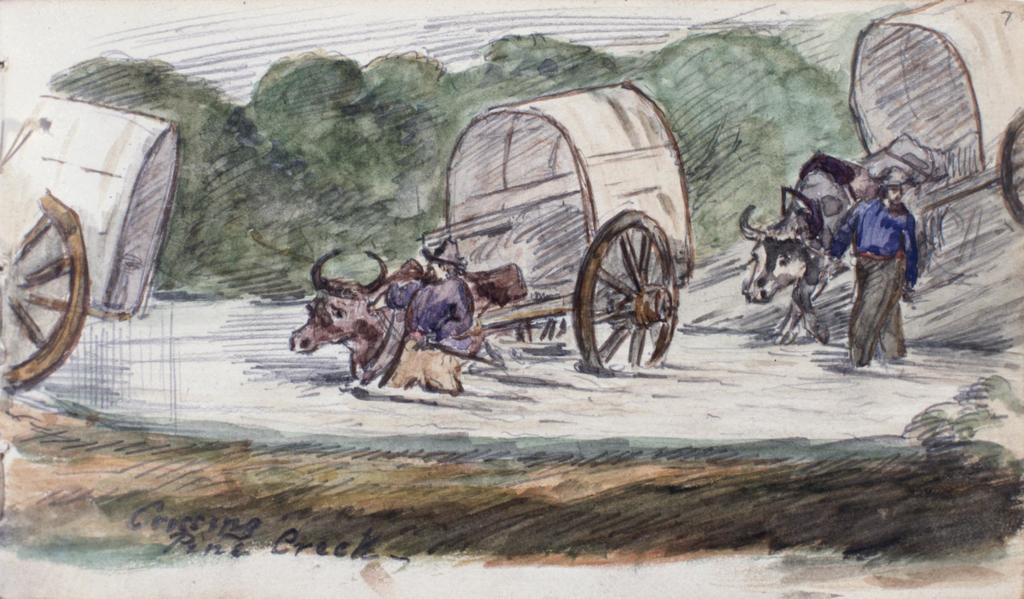In one or two sentences, can you explain what this image depicts? In this image we can see a painting of three cats, two animals, and a person wearing blue shirt. In the background, we can see a group of trees. 